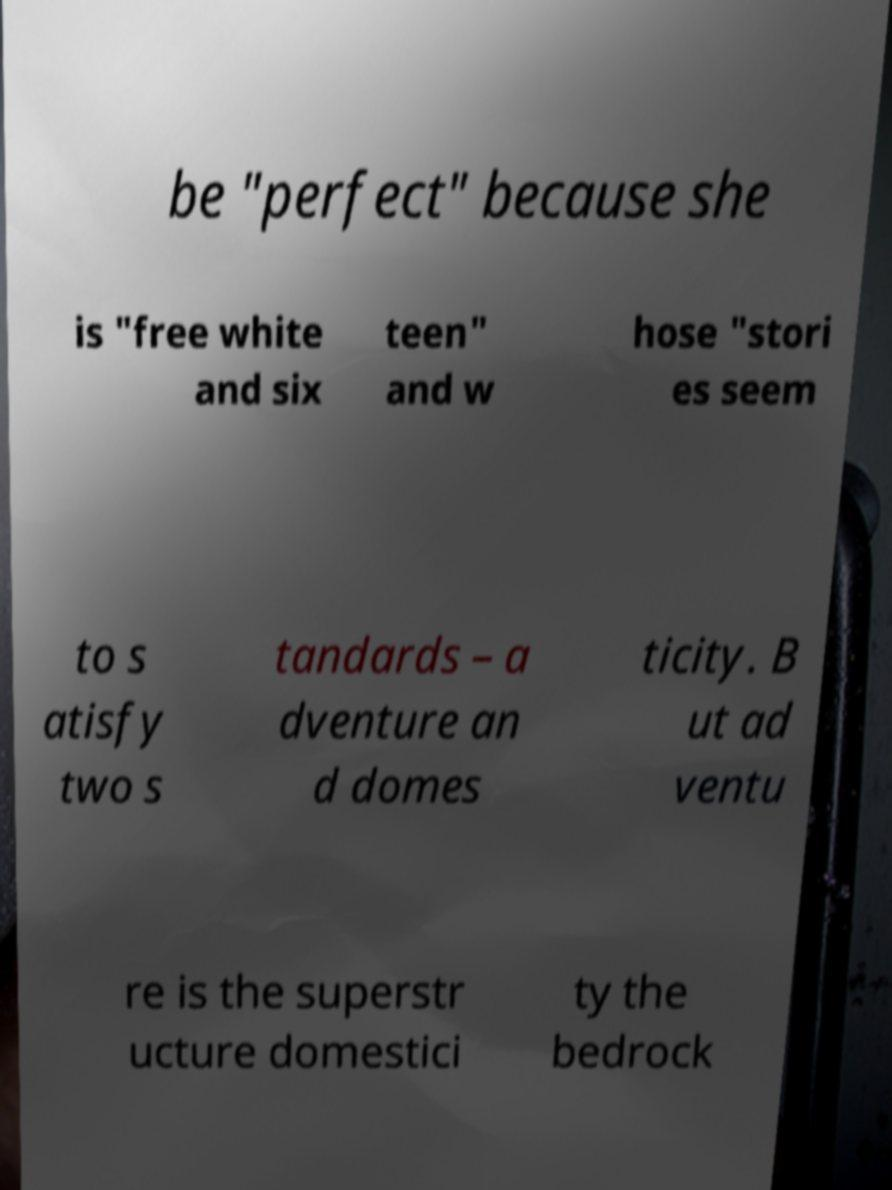Please read and relay the text visible in this image. What does it say? be "perfect" because she is "free white and six teen" and w hose "stori es seem to s atisfy two s tandards – a dventure an d domes ticity. B ut ad ventu re is the superstr ucture domestici ty the bedrock 